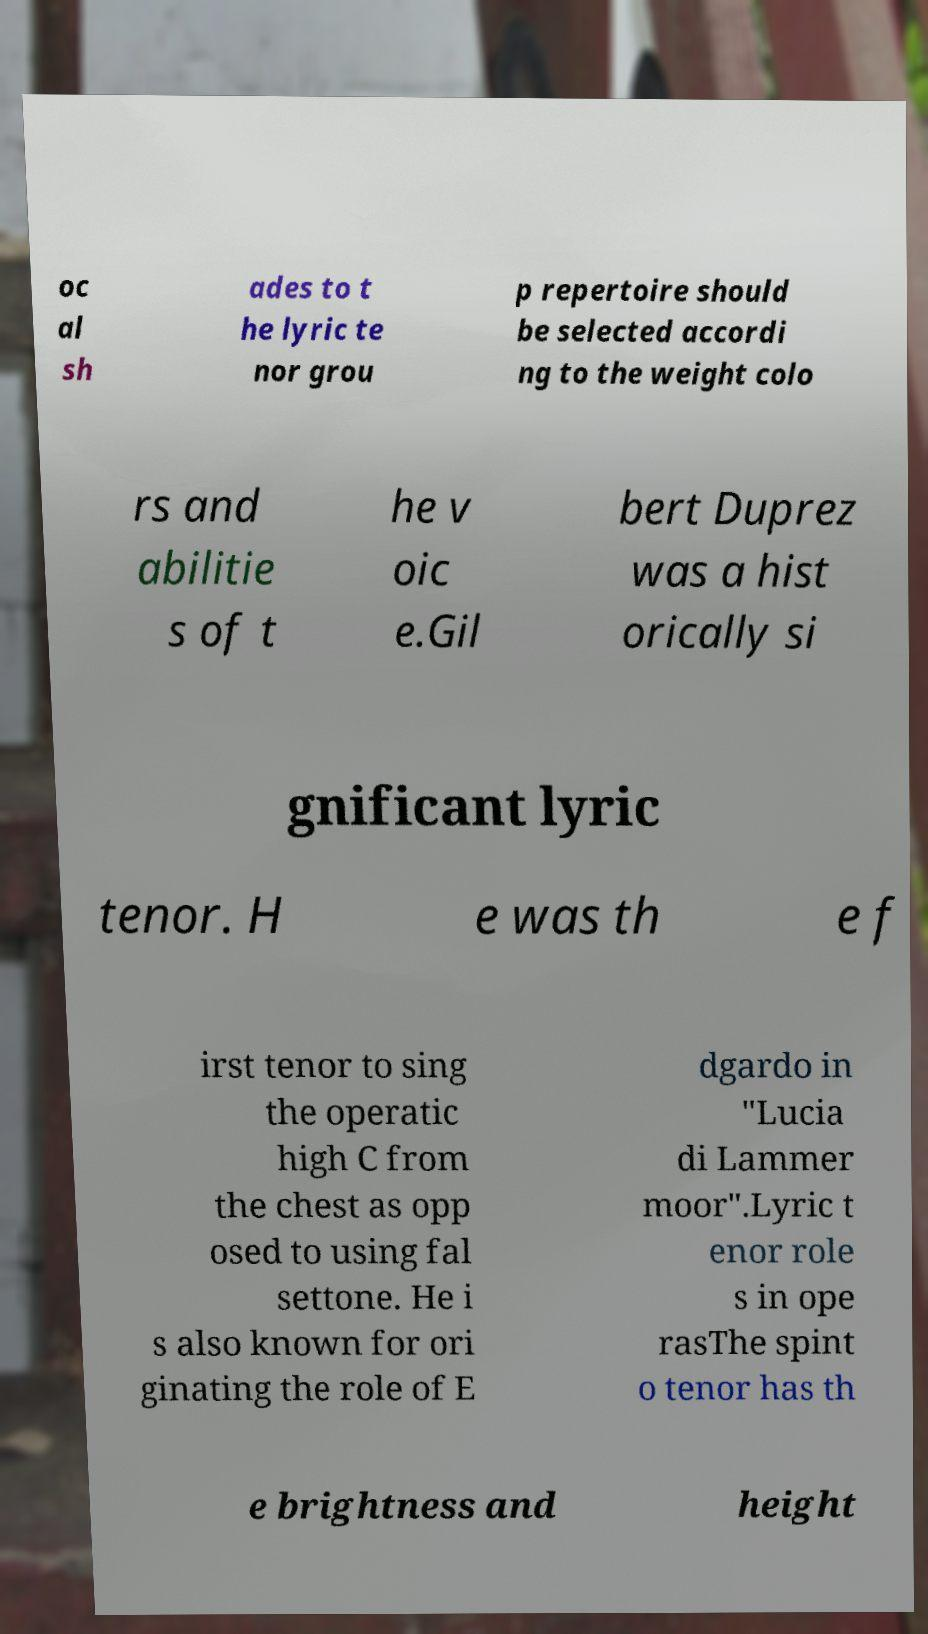I need the written content from this picture converted into text. Can you do that? oc al sh ades to t he lyric te nor grou p repertoire should be selected accordi ng to the weight colo rs and abilitie s of t he v oic e.Gil bert Duprez was a hist orically si gnificant lyric tenor. H e was th e f irst tenor to sing the operatic high C from the chest as opp osed to using fal settone. He i s also known for ori ginating the role of E dgardo in "Lucia di Lammer moor".Lyric t enor role s in ope rasThe spint o tenor has th e brightness and height 